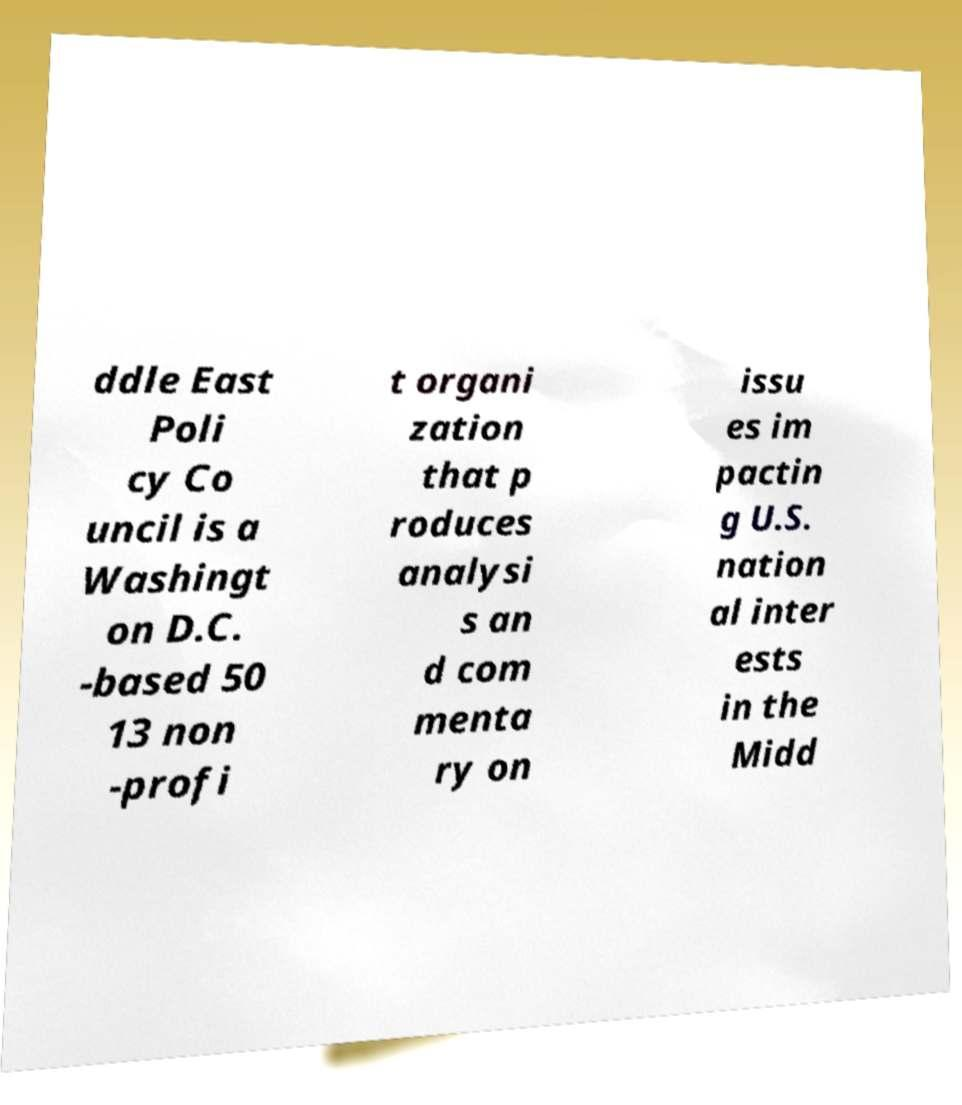What messages or text are displayed in this image? I need them in a readable, typed format. ddle East Poli cy Co uncil is a Washingt on D.C. -based 50 13 non -profi t organi zation that p roduces analysi s an d com menta ry on issu es im pactin g U.S. nation al inter ests in the Midd 